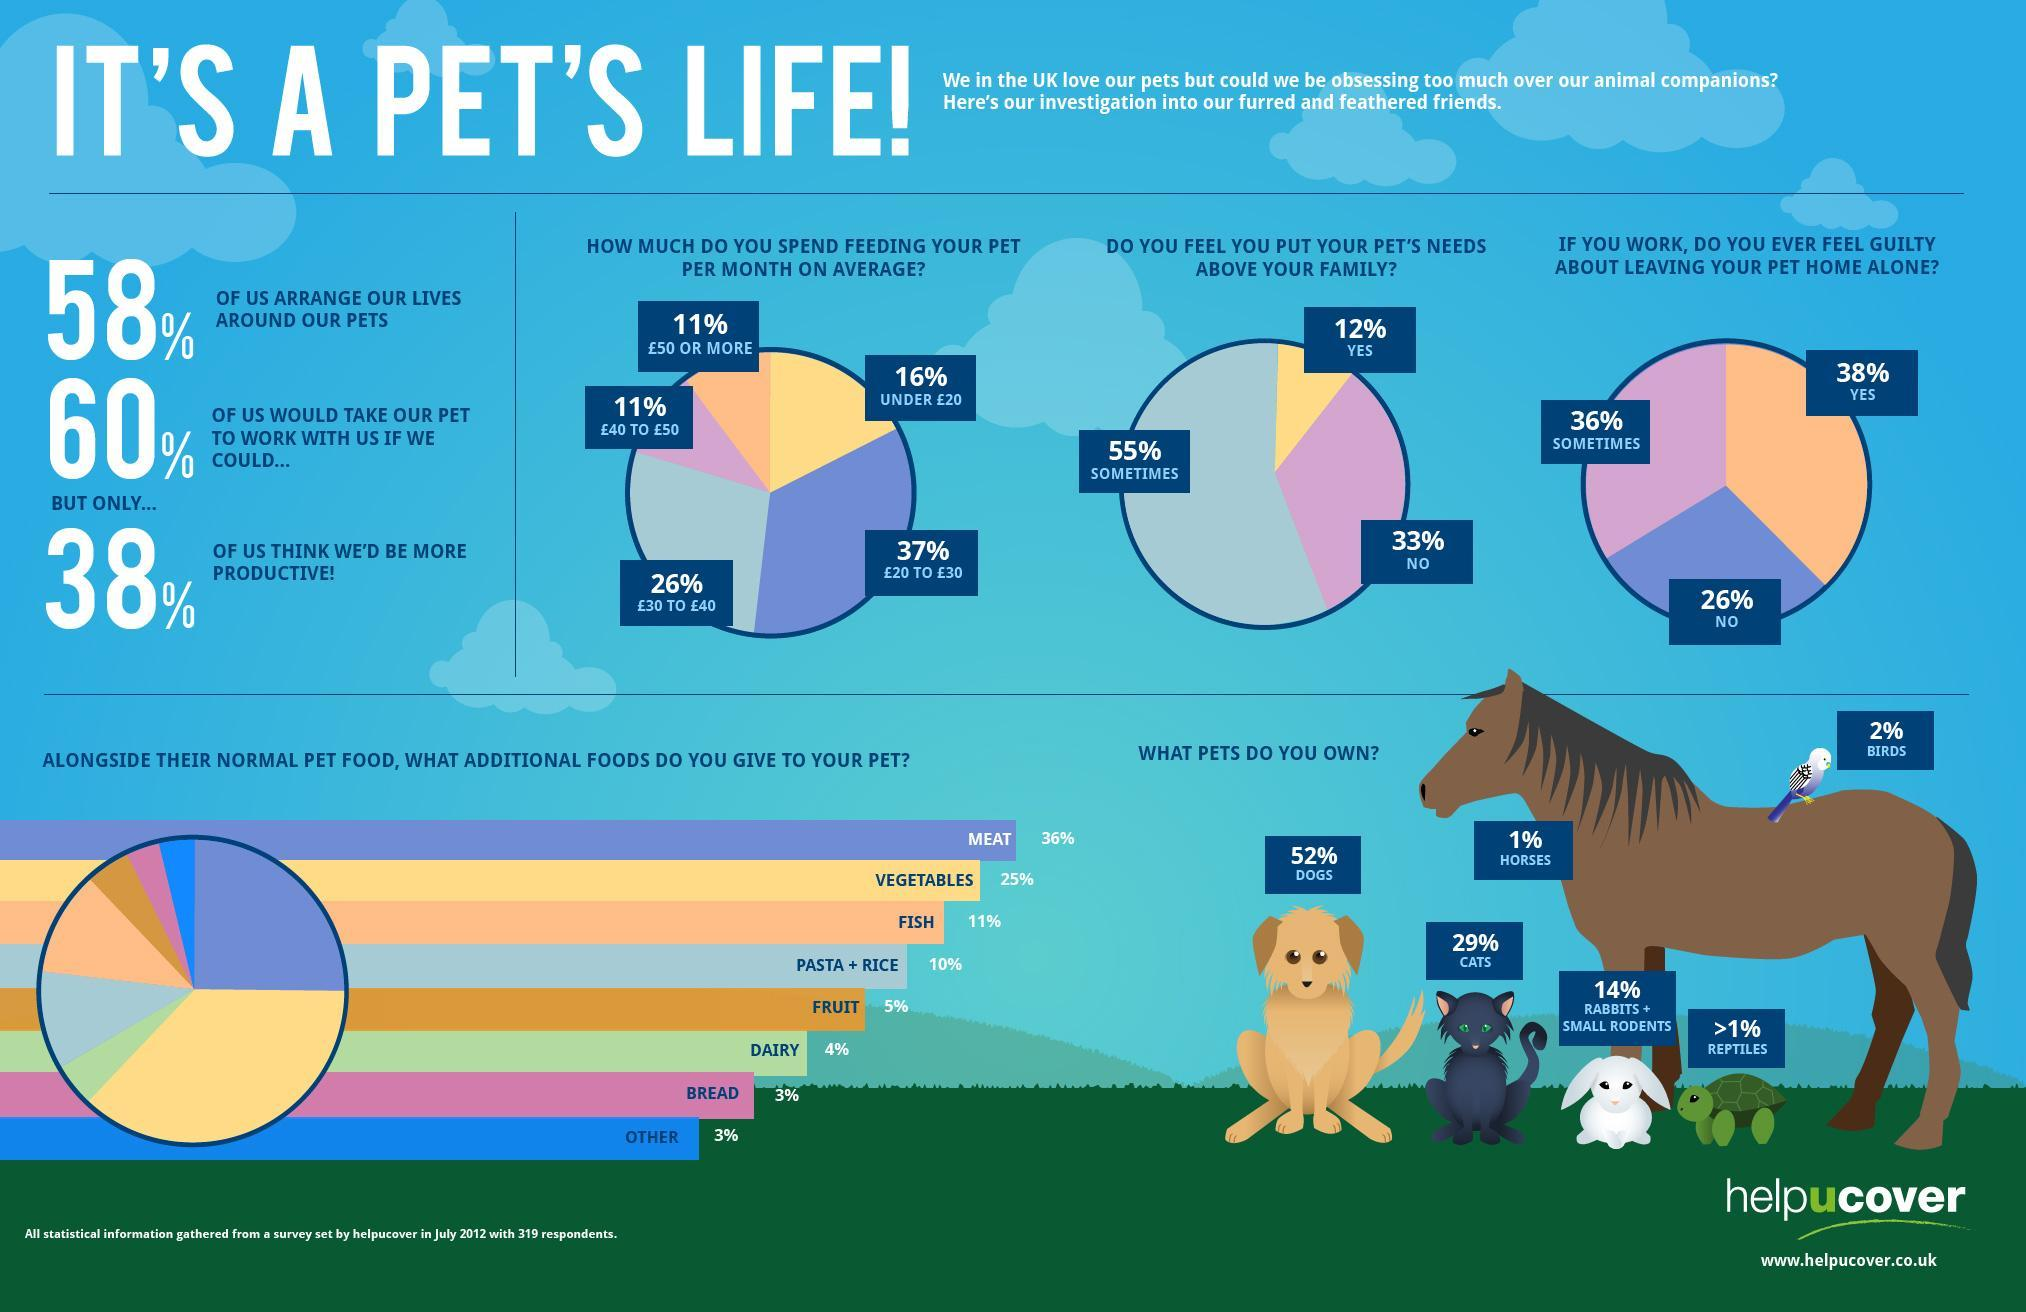What percent of owners do not feel guilty about leaving their pets alone at home ?
Answer the question with a short phrase. 26% What percent of owners keep birds as pets ? 2% Which are the least common pets ? Reptiles What percentage of pet owners own dogs ? 52% Which of these animals is  most commonly kept as pet - horses, birds or reptiles? Birds What is the second most commonly given additional food for pets ? Vegetables What percentage of owners always put their pets above their family? 12% What percent of pet owners own horses ? 1% What percent of the owners do not like to take pets to their workplace ? 40% By what percent are dog owners more than cat owners ? 23% 